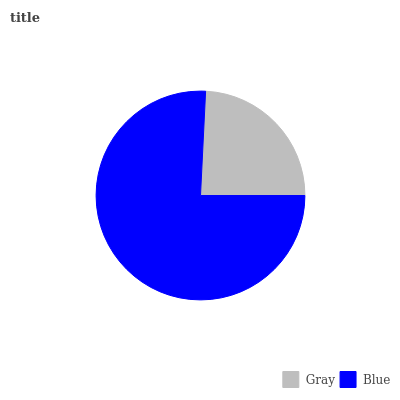Is Gray the minimum?
Answer yes or no. Yes. Is Blue the maximum?
Answer yes or no. Yes. Is Blue the minimum?
Answer yes or no. No. Is Blue greater than Gray?
Answer yes or no. Yes. Is Gray less than Blue?
Answer yes or no. Yes. Is Gray greater than Blue?
Answer yes or no. No. Is Blue less than Gray?
Answer yes or no. No. Is Blue the high median?
Answer yes or no. Yes. Is Gray the low median?
Answer yes or no. Yes. Is Gray the high median?
Answer yes or no. No. Is Blue the low median?
Answer yes or no. No. 